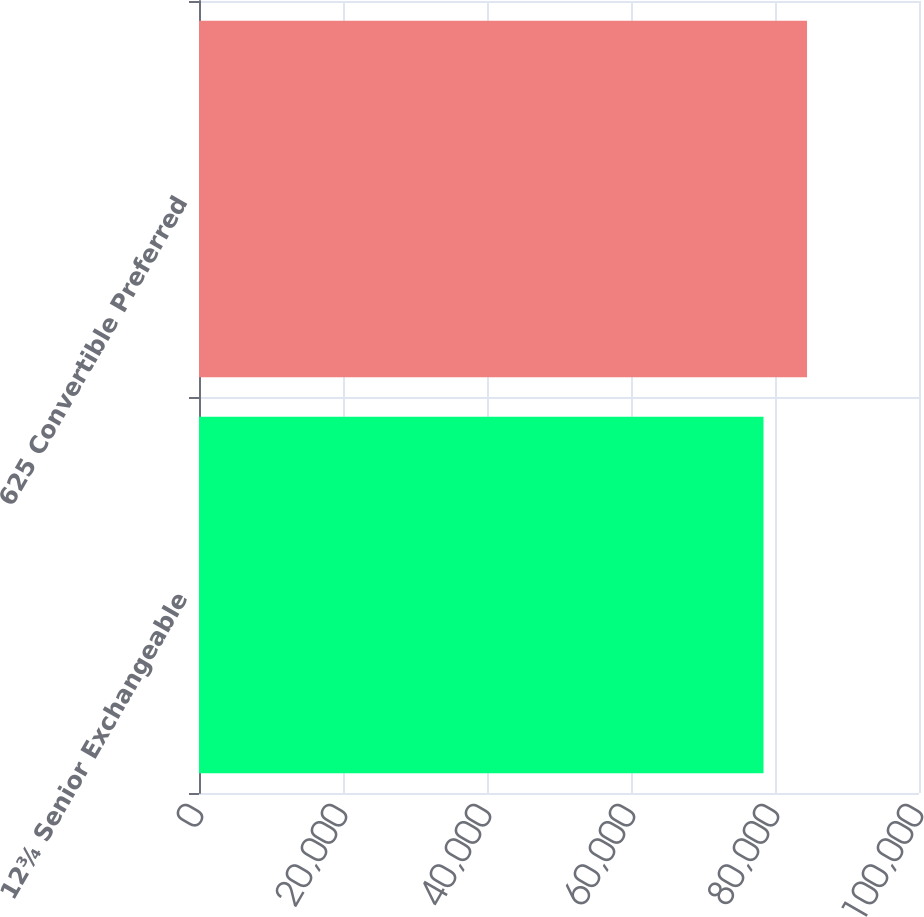Convert chart to OTSL. <chart><loc_0><loc_0><loc_500><loc_500><bar_chart><fcel>12¾ Senior Exchangeable<fcel>625 Convertible Preferred<nl><fcel>78403<fcel>84450<nl></chart> 